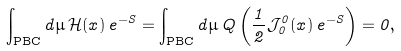<formula> <loc_0><loc_0><loc_500><loc_500>\int _ { \text {PBC} } d \mu \, \mathcal { H } ( x ) \, e ^ { - S } = \int _ { \text {PBC} } d \mu \, Q \left ( \frac { 1 } { 2 } \mathcal { J } _ { 0 } ^ { 0 } ( x ) \, e ^ { - S } \right ) = 0 ,</formula> 